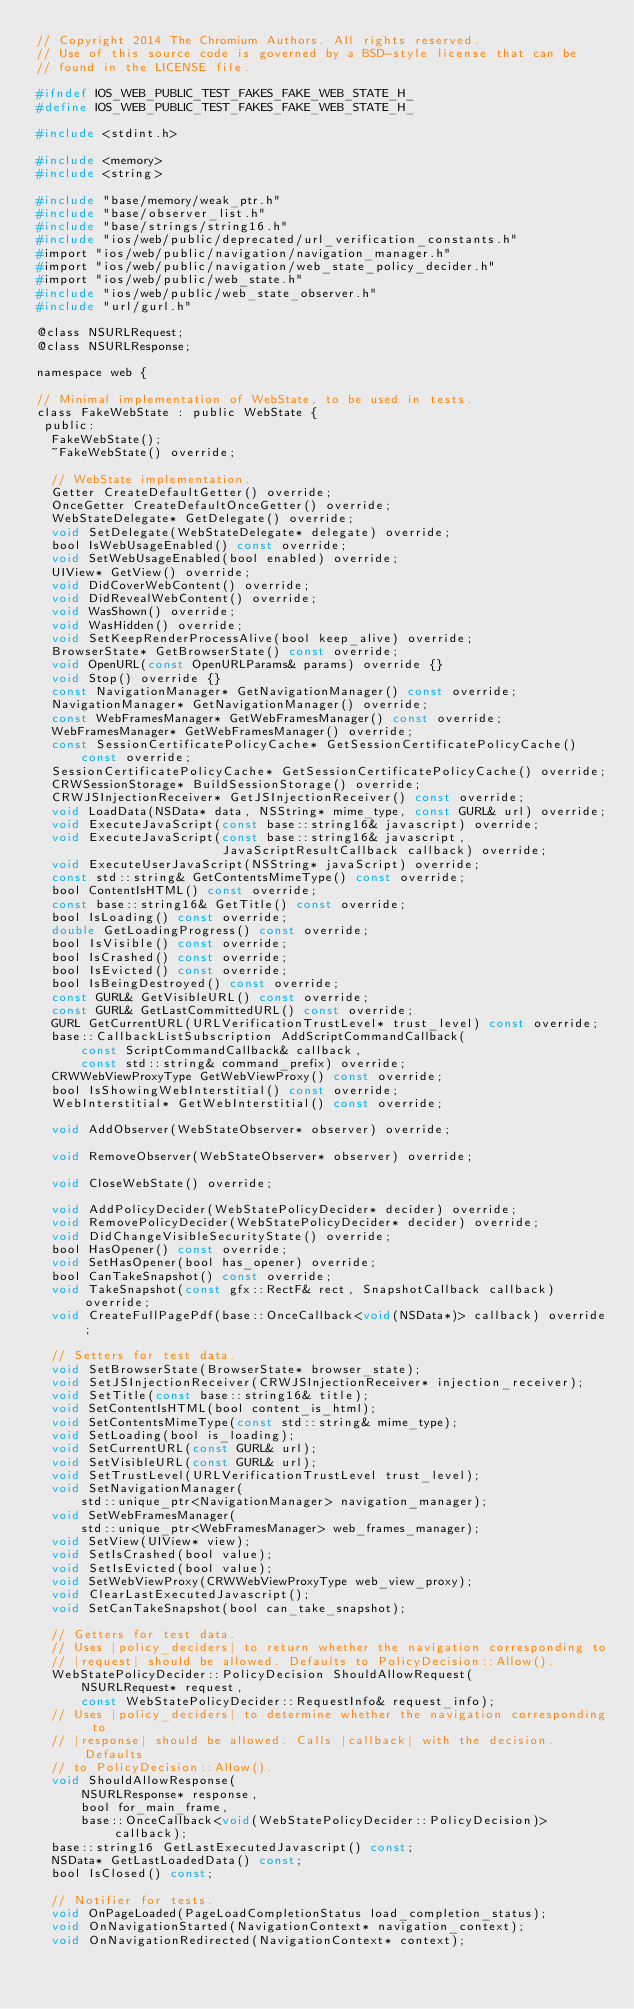<code> <loc_0><loc_0><loc_500><loc_500><_C_>// Copyright 2014 The Chromium Authors. All rights reserved.
// Use of this source code is governed by a BSD-style license that can be
// found in the LICENSE file.

#ifndef IOS_WEB_PUBLIC_TEST_FAKES_FAKE_WEB_STATE_H_
#define IOS_WEB_PUBLIC_TEST_FAKES_FAKE_WEB_STATE_H_

#include <stdint.h>

#include <memory>
#include <string>

#include "base/memory/weak_ptr.h"
#include "base/observer_list.h"
#include "base/strings/string16.h"
#include "ios/web/public/deprecated/url_verification_constants.h"
#import "ios/web/public/navigation/navigation_manager.h"
#import "ios/web/public/navigation/web_state_policy_decider.h"
#import "ios/web/public/web_state.h"
#include "ios/web/public/web_state_observer.h"
#include "url/gurl.h"

@class NSURLRequest;
@class NSURLResponse;

namespace web {

// Minimal implementation of WebState, to be used in tests.
class FakeWebState : public WebState {
 public:
  FakeWebState();
  ~FakeWebState() override;

  // WebState implementation.
  Getter CreateDefaultGetter() override;
  OnceGetter CreateDefaultOnceGetter() override;
  WebStateDelegate* GetDelegate() override;
  void SetDelegate(WebStateDelegate* delegate) override;
  bool IsWebUsageEnabled() const override;
  void SetWebUsageEnabled(bool enabled) override;
  UIView* GetView() override;
  void DidCoverWebContent() override;
  void DidRevealWebContent() override;
  void WasShown() override;
  void WasHidden() override;
  void SetKeepRenderProcessAlive(bool keep_alive) override;
  BrowserState* GetBrowserState() const override;
  void OpenURL(const OpenURLParams& params) override {}
  void Stop() override {}
  const NavigationManager* GetNavigationManager() const override;
  NavigationManager* GetNavigationManager() override;
  const WebFramesManager* GetWebFramesManager() const override;
  WebFramesManager* GetWebFramesManager() override;
  const SessionCertificatePolicyCache* GetSessionCertificatePolicyCache()
      const override;
  SessionCertificatePolicyCache* GetSessionCertificatePolicyCache() override;
  CRWSessionStorage* BuildSessionStorage() override;
  CRWJSInjectionReceiver* GetJSInjectionReceiver() const override;
  void LoadData(NSData* data, NSString* mime_type, const GURL& url) override;
  void ExecuteJavaScript(const base::string16& javascript) override;
  void ExecuteJavaScript(const base::string16& javascript,
                         JavaScriptResultCallback callback) override;
  void ExecuteUserJavaScript(NSString* javaScript) override;
  const std::string& GetContentsMimeType() const override;
  bool ContentIsHTML() const override;
  const base::string16& GetTitle() const override;
  bool IsLoading() const override;
  double GetLoadingProgress() const override;
  bool IsVisible() const override;
  bool IsCrashed() const override;
  bool IsEvicted() const override;
  bool IsBeingDestroyed() const override;
  const GURL& GetVisibleURL() const override;
  const GURL& GetLastCommittedURL() const override;
  GURL GetCurrentURL(URLVerificationTrustLevel* trust_level) const override;
  base::CallbackListSubscription AddScriptCommandCallback(
      const ScriptCommandCallback& callback,
      const std::string& command_prefix) override;
  CRWWebViewProxyType GetWebViewProxy() const override;
  bool IsShowingWebInterstitial() const override;
  WebInterstitial* GetWebInterstitial() const override;

  void AddObserver(WebStateObserver* observer) override;

  void RemoveObserver(WebStateObserver* observer) override;

  void CloseWebState() override;

  void AddPolicyDecider(WebStatePolicyDecider* decider) override;
  void RemovePolicyDecider(WebStatePolicyDecider* decider) override;
  void DidChangeVisibleSecurityState() override;
  bool HasOpener() const override;
  void SetHasOpener(bool has_opener) override;
  bool CanTakeSnapshot() const override;
  void TakeSnapshot(const gfx::RectF& rect, SnapshotCallback callback) override;
  void CreateFullPagePdf(base::OnceCallback<void(NSData*)> callback) override;

  // Setters for test data.
  void SetBrowserState(BrowserState* browser_state);
  void SetJSInjectionReceiver(CRWJSInjectionReceiver* injection_receiver);
  void SetTitle(const base::string16& title);
  void SetContentIsHTML(bool content_is_html);
  void SetContentsMimeType(const std::string& mime_type);
  void SetLoading(bool is_loading);
  void SetCurrentURL(const GURL& url);
  void SetVisibleURL(const GURL& url);
  void SetTrustLevel(URLVerificationTrustLevel trust_level);
  void SetNavigationManager(
      std::unique_ptr<NavigationManager> navigation_manager);
  void SetWebFramesManager(
      std::unique_ptr<WebFramesManager> web_frames_manager);
  void SetView(UIView* view);
  void SetIsCrashed(bool value);
  void SetIsEvicted(bool value);
  void SetWebViewProxy(CRWWebViewProxyType web_view_proxy);
  void ClearLastExecutedJavascript();
  void SetCanTakeSnapshot(bool can_take_snapshot);

  // Getters for test data.
  // Uses |policy_deciders| to return whether the navigation corresponding to
  // |request| should be allowed. Defaults to PolicyDecision::Allow().
  WebStatePolicyDecider::PolicyDecision ShouldAllowRequest(
      NSURLRequest* request,
      const WebStatePolicyDecider::RequestInfo& request_info);
  // Uses |policy_deciders| to determine whether the navigation corresponding to
  // |response| should be allowed. Calls |callback| with the decision. Defaults
  // to PolicyDecision::Allow().
  void ShouldAllowResponse(
      NSURLResponse* response,
      bool for_main_frame,
      base::OnceCallback<void(WebStatePolicyDecider::PolicyDecision)> callback);
  base::string16 GetLastExecutedJavascript() const;
  NSData* GetLastLoadedData() const;
  bool IsClosed() const;

  // Notifier for tests.
  void OnPageLoaded(PageLoadCompletionStatus load_completion_status);
  void OnNavigationStarted(NavigationContext* navigation_context);
  void OnNavigationRedirected(NavigationContext* context);</code> 